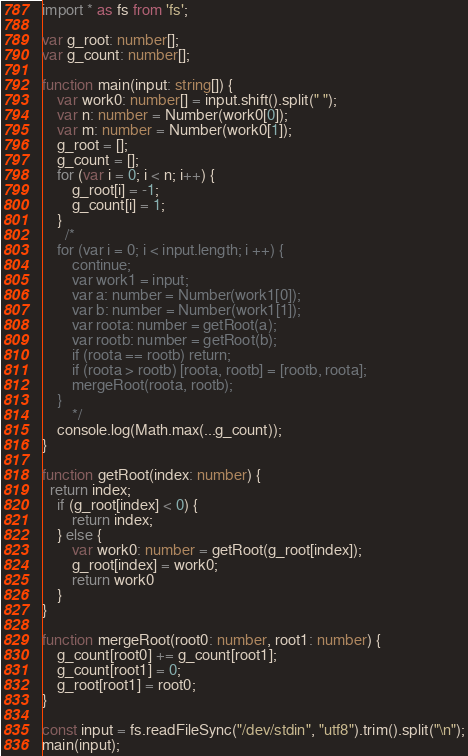Convert code to text. <code><loc_0><loc_0><loc_500><loc_500><_TypeScript_>import * as fs from 'fs';

var g_root: number[];
var g_count: number[];

function main(input: string[]) {
	var work0: number[] = input.shift().split(" ");
	var n: number = Number(work0[0]);
	var m: number = Number(work0[1]);
	g_root = [];
  	g_count = [];
    for (var i = 0; i < n; i++) {
        g_root[i] = -1;
        g_count[i] = 1;
    }
      /*
  	for (var i = 0; i < input.length; i ++) {
		continue;
      	var work1 = input;
		var a: number = Number(work1[0]);
		var b: number = Number(work1[1]);
		var roota: number = getRoot(a);
		var rootb: number = getRoot(b);
		if (roota == rootb) return;
		if (roota > rootb) [roota, rootb] = [rootb, roota];
		mergeRoot(roota, rootb);
	}
        */
	console.log(Math.max(...g_count));
}

function getRoot(index: number) {
  return index;
	if (g_root[index] < 0) {
		return index;
	} else {
		var work0: number = getRoot(g_root[index]);
		g_root[index] = work0;
		return work0
	}
}

function mergeRoot(root0: number, root1: number) {
	g_count[root0] += g_count[root1];
	g_count[root1] = 0;
	g_root[root1] = root0;
}

const input = fs.readFileSync("/dev/stdin", "utf8").trim().split("\n");
main(input);
</code> 